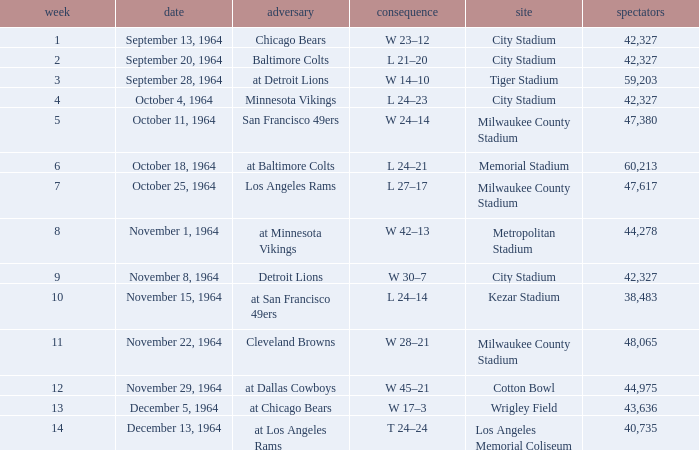What is the average attendance at a week 4 game? 42327.0. 